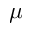<formula> <loc_0><loc_0><loc_500><loc_500>\mu</formula> 